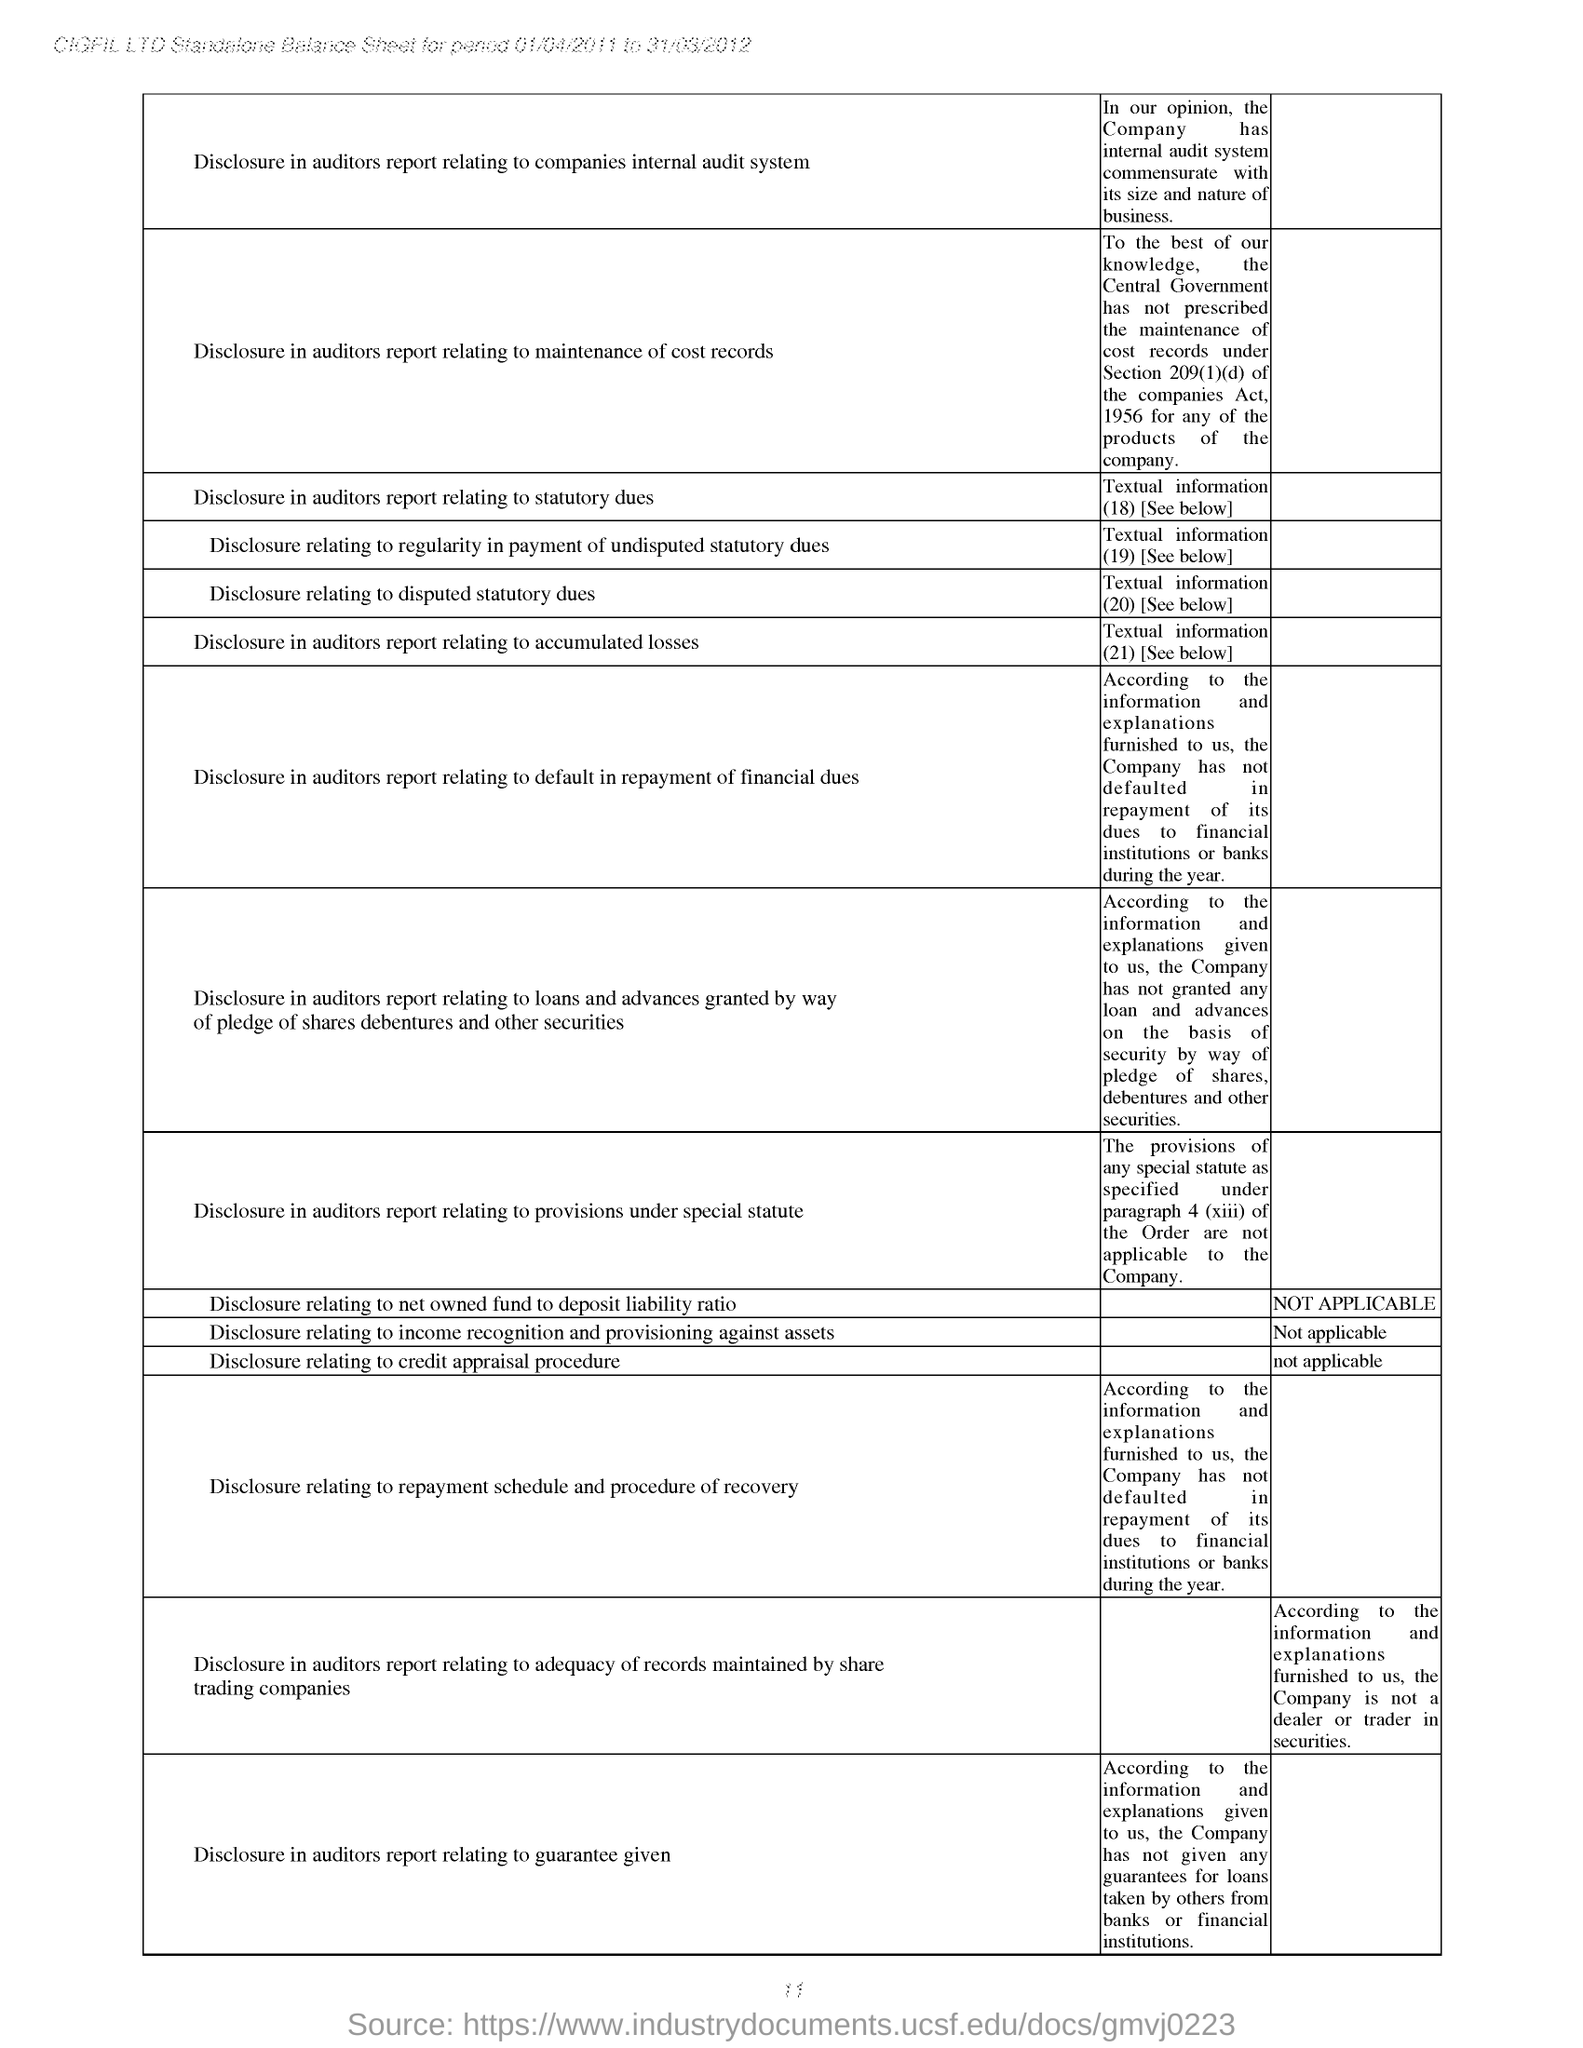What is the company name provided at the top of the balance sheet?
Provide a short and direct response. CIGFIL LTD. CIGFIL LTD Standalone Balance Sheet given is for which period?
Offer a terse response. 01/04/2011 to 31/03/2012. Provide the first DISCLOSURE mentioned in the Balance Sheet?
Keep it short and to the point. Disclosure in auditors report relating to companies internal audit system. Provide the last DISCLOSURE mentioned in the Balance Sheet?
Give a very brief answer. Disclosure in auditors report relating to guarantee given. 